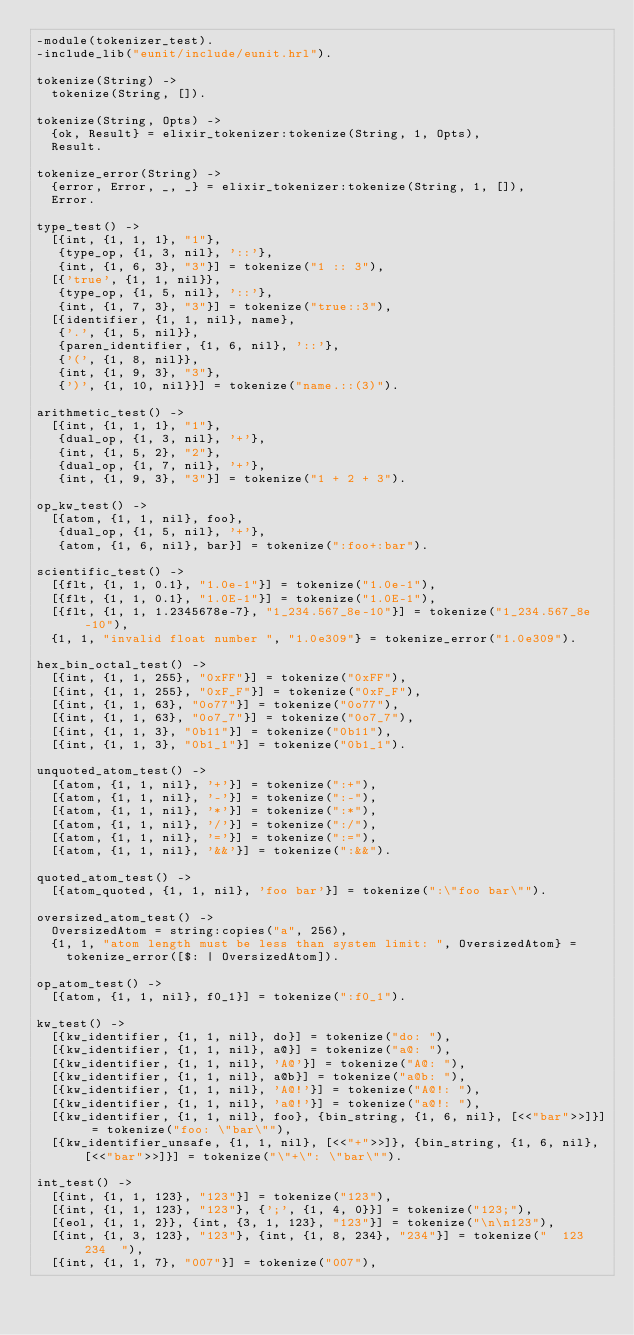<code> <loc_0><loc_0><loc_500><loc_500><_Erlang_>-module(tokenizer_test).
-include_lib("eunit/include/eunit.hrl").

tokenize(String) ->
  tokenize(String, []).

tokenize(String, Opts) ->
  {ok, Result} = elixir_tokenizer:tokenize(String, 1, Opts),
  Result.

tokenize_error(String) ->
  {error, Error, _, _} = elixir_tokenizer:tokenize(String, 1, []),
  Error.

type_test() ->
  [{int, {1, 1, 1}, "1"},
   {type_op, {1, 3, nil}, '::'},
   {int, {1, 6, 3}, "3"}] = tokenize("1 :: 3"),
  [{'true', {1, 1, nil}},
   {type_op, {1, 5, nil}, '::'},
   {int, {1, 7, 3}, "3"}] = tokenize("true::3"),
  [{identifier, {1, 1, nil}, name},
   {'.', {1, 5, nil}},
   {paren_identifier, {1, 6, nil}, '::'},
   {'(', {1, 8, nil}},
   {int, {1, 9, 3}, "3"},
   {')', {1, 10, nil}}] = tokenize("name.::(3)").

arithmetic_test() ->
  [{int, {1, 1, 1}, "1"},
   {dual_op, {1, 3, nil}, '+'},
   {int, {1, 5, 2}, "2"},
   {dual_op, {1, 7, nil}, '+'},
   {int, {1, 9, 3}, "3"}] = tokenize("1 + 2 + 3").

op_kw_test() ->
  [{atom, {1, 1, nil}, foo},
   {dual_op, {1, 5, nil}, '+'},
   {atom, {1, 6, nil}, bar}] = tokenize(":foo+:bar").

scientific_test() ->
  [{flt, {1, 1, 0.1}, "1.0e-1"}] = tokenize("1.0e-1"),
  [{flt, {1, 1, 0.1}, "1.0E-1"}] = tokenize("1.0E-1"),
  [{flt, {1, 1, 1.2345678e-7}, "1_234.567_8e-10"}] = tokenize("1_234.567_8e-10"),
  {1, 1, "invalid float number ", "1.0e309"} = tokenize_error("1.0e309").

hex_bin_octal_test() ->
  [{int, {1, 1, 255}, "0xFF"}] = tokenize("0xFF"),
  [{int, {1, 1, 255}, "0xF_F"}] = tokenize("0xF_F"),
  [{int, {1, 1, 63}, "0o77"}] = tokenize("0o77"),
  [{int, {1, 1, 63}, "0o7_7"}] = tokenize("0o7_7"),
  [{int, {1, 1, 3}, "0b11"}] = tokenize("0b11"),
  [{int, {1, 1, 3}, "0b1_1"}] = tokenize("0b1_1").

unquoted_atom_test() ->
  [{atom, {1, 1, nil}, '+'}] = tokenize(":+"),
  [{atom, {1, 1, nil}, '-'}] = tokenize(":-"),
  [{atom, {1, 1, nil}, '*'}] = tokenize(":*"),
  [{atom, {1, 1, nil}, '/'}] = tokenize(":/"),
  [{atom, {1, 1, nil}, '='}] = tokenize(":="),
  [{atom, {1, 1, nil}, '&&'}] = tokenize(":&&").

quoted_atom_test() ->
  [{atom_quoted, {1, 1, nil}, 'foo bar'}] = tokenize(":\"foo bar\"").

oversized_atom_test() ->
  OversizedAtom = string:copies("a", 256),
  {1, 1, "atom length must be less than system limit: ", OversizedAtom} =
    tokenize_error([$: | OversizedAtom]).

op_atom_test() ->
  [{atom, {1, 1, nil}, f0_1}] = tokenize(":f0_1").

kw_test() ->
  [{kw_identifier, {1, 1, nil}, do}] = tokenize("do: "),
  [{kw_identifier, {1, 1, nil}, a@}] = tokenize("a@: "),
  [{kw_identifier, {1, 1, nil}, 'A@'}] = tokenize("A@: "),
  [{kw_identifier, {1, 1, nil}, a@b}] = tokenize("a@b: "),
  [{kw_identifier, {1, 1, nil}, 'A@!'}] = tokenize("A@!: "),
  [{kw_identifier, {1, 1, nil}, 'a@!'}] = tokenize("a@!: "),
  [{kw_identifier, {1, 1, nil}, foo}, {bin_string, {1, 6, nil}, [<<"bar">>]}] = tokenize("foo: \"bar\""),
  [{kw_identifier_unsafe, {1, 1, nil}, [<<"+">>]}, {bin_string, {1, 6, nil}, [<<"bar">>]}] = tokenize("\"+\": \"bar\"").

int_test() ->
  [{int, {1, 1, 123}, "123"}] = tokenize("123"),
  [{int, {1, 1, 123}, "123"}, {';', {1, 4, 0}}] = tokenize("123;"),
  [{eol, {1, 1, 2}}, {int, {3, 1, 123}, "123"}] = tokenize("\n\n123"),
  [{int, {1, 3, 123}, "123"}, {int, {1, 8, 234}, "234"}] = tokenize("  123  234  "),
  [{int, {1, 1, 7}, "007"}] = tokenize("007"),</code> 